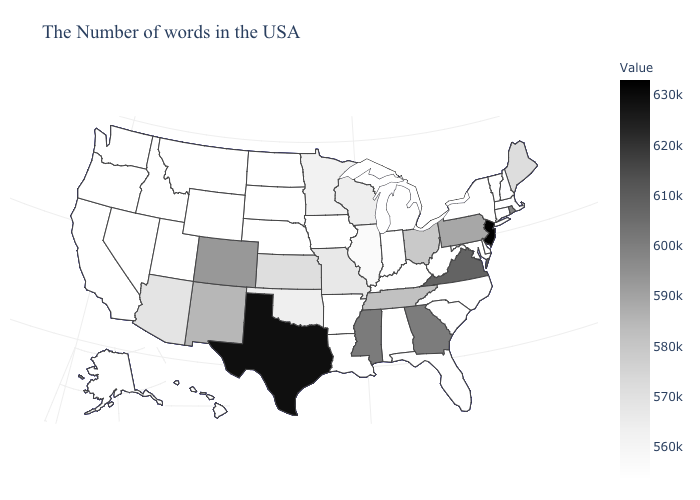Among the states that border Delaware , which have the highest value?
Keep it brief. New Jersey. Which states hav the highest value in the MidWest?
Be succinct. Ohio. Does South Dakota have the lowest value in the USA?
Answer briefly. Yes. Among the states that border Georgia , does North Carolina have the highest value?
Be succinct. No. Among the states that border New York , does Vermont have the highest value?
Answer briefly. No. Among the states that border Kansas , which have the highest value?
Short answer required. Colorado. Which states have the highest value in the USA?
Give a very brief answer. New Jersey. 